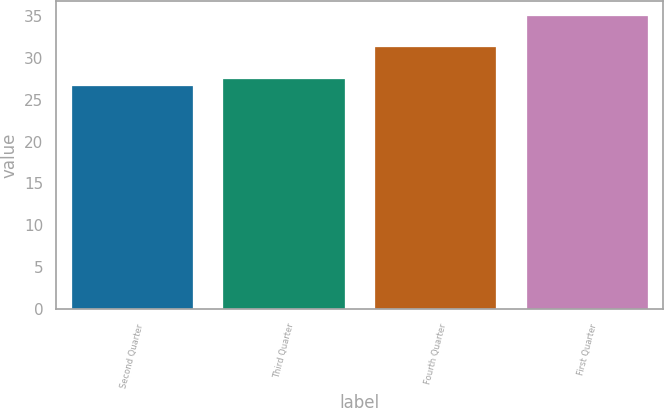<chart> <loc_0><loc_0><loc_500><loc_500><bar_chart><fcel>Second Quarter<fcel>Third Quarter<fcel>Fourth Quarter<fcel>First Quarter<nl><fcel>26.59<fcel>27.43<fcel>31.29<fcel>35.01<nl></chart> 